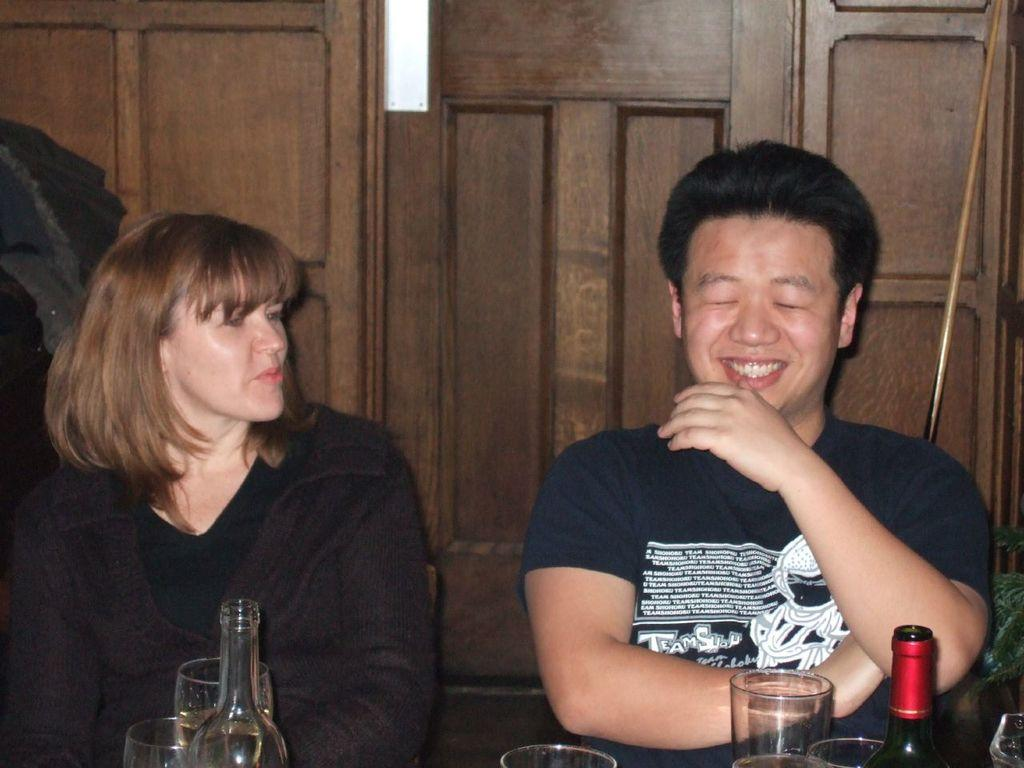How many people are in the image? There are two people in the image, a man and a woman. What are the man and woman doing in the image? Both the man and woman are sitting on chairs. What objects can be seen related to drinking in the image? There are two bottles and two glasses in the image. What type of material can be seen in the background of the image? There is a wooden wall in the background of the image. What is the position of the stick in the image? There is a stick placed in the corner of the image. What type of class is being taught in the image? There is no class or teaching activity depicted in the image. Can you see a plane flying in the image? There is no plane visible in the image. 